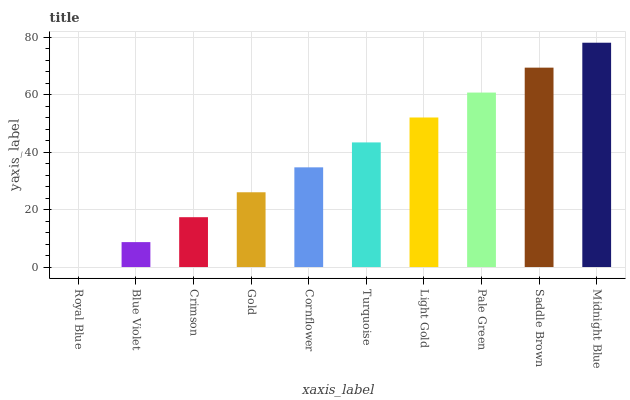Is Royal Blue the minimum?
Answer yes or no. Yes. Is Midnight Blue the maximum?
Answer yes or no. Yes. Is Blue Violet the minimum?
Answer yes or no. No. Is Blue Violet the maximum?
Answer yes or no. No. Is Blue Violet greater than Royal Blue?
Answer yes or no. Yes. Is Royal Blue less than Blue Violet?
Answer yes or no. Yes. Is Royal Blue greater than Blue Violet?
Answer yes or no. No. Is Blue Violet less than Royal Blue?
Answer yes or no. No. Is Turquoise the high median?
Answer yes or no. Yes. Is Cornflower the low median?
Answer yes or no. Yes. Is Blue Violet the high median?
Answer yes or no. No. Is Crimson the low median?
Answer yes or no. No. 